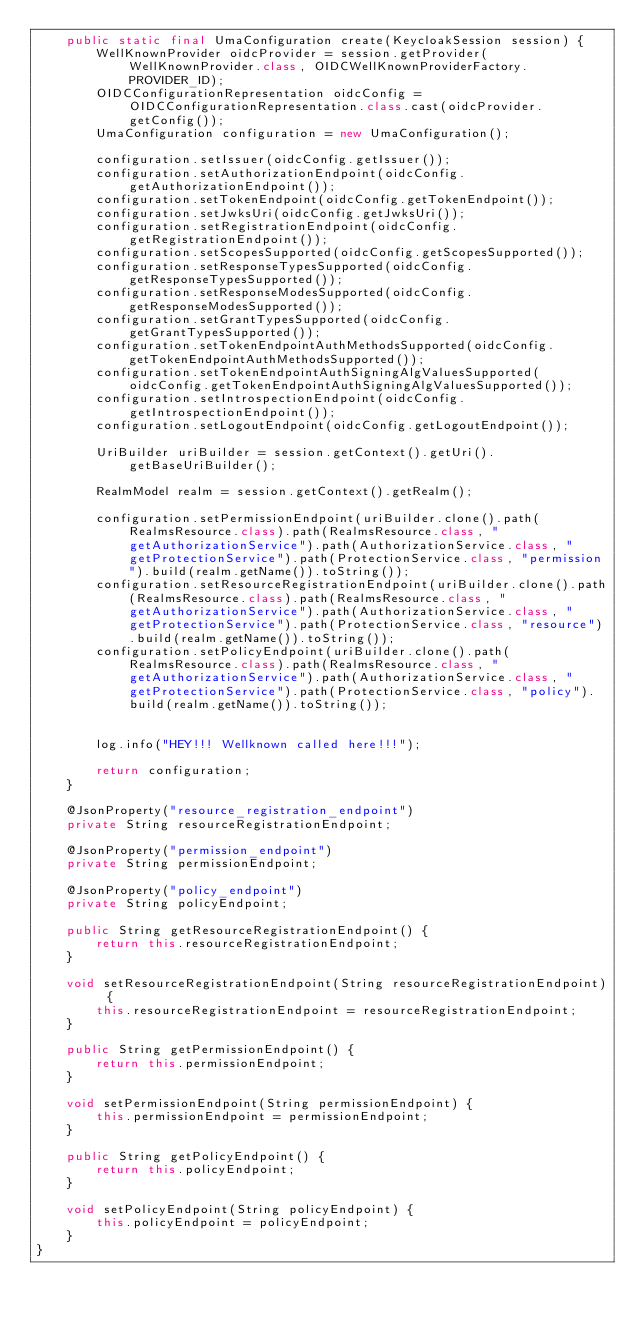Convert code to text. <code><loc_0><loc_0><loc_500><loc_500><_Java_>    public static final UmaConfiguration create(KeycloakSession session) {
        WellKnownProvider oidcProvider = session.getProvider(WellKnownProvider.class, OIDCWellKnownProviderFactory.PROVIDER_ID);
        OIDCConfigurationRepresentation oidcConfig = OIDCConfigurationRepresentation.class.cast(oidcProvider.getConfig());
        UmaConfiguration configuration = new UmaConfiguration();

        configuration.setIssuer(oidcConfig.getIssuer());
        configuration.setAuthorizationEndpoint(oidcConfig.getAuthorizationEndpoint());
        configuration.setTokenEndpoint(oidcConfig.getTokenEndpoint());
        configuration.setJwksUri(oidcConfig.getJwksUri());
        configuration.setRegistrationEndpoint(oidcConfig.getRegistrationEndpoint());
        configuration.setScopesSupported(oidcConfig.getScopesSupported());
        configuration.setResponseTypesSupported(oidcConfig.getResponseTypesSupported());
        configuration.setResponseModesSupported(oidcConfig.getResponseModesSupported());
        configuration.setGrantTypesSupported(oidcConfig.getGrantTypesSupported());
        configuration.setTokenEndpointAuthMethodsSupported(oidcConfig.getTokenEndpointAuthMethodsSupported());
        configuration.setTokenEndpointAuthSigningAlgValuesSupported(oidcConfig.getTokenEndpointAuthSigningAlgValuesSupported());
        configuration.setIntrospectionEndpoint(oidcConfig.getIntrospectionEndpoint());
        configuration.setLogoutEndpoint(oidcConfig.getLogoutEndpoint());

        UriBuilder uriBuilder = session.getContext().getUri().getBaseUriBuilder();

        RealmModel realm = session.getContext().getRealm();

        configuration.setPermissionEndpoint(uriBuilder.clone().path(RealmsResource.class).path(RealmsResource.class, "getAuthorizationService").path(AuthorizationService.class, "getProtectionService").path(ProtectionService.class, "permission").build(realm.getName()).toString());
        configuration.setResourceRegistrationEndpoint(uriBuilder.clone().path(RealmsResource.class).path(RealmsResource.class, "getAuthorizationService").path(AuthorizationService.class, "getProtectionService").path(ProtectionService.class, "resource").build(realm.getName()).toString());
        configuration.setPolicyEndpoint(uriBuilder.clone().path(RealmsResource.class).path(RealmsResource.class, "getAuthorizationService").path(AuthorizationService.class, "getProtectionService").path(ProtectionService.class, "policy").build(realm.getName()).toString());


        log.info("HEY!!! Wellknown called here!!!");

        return configuration;
    }

    @JsonProperty("resource_registration_endpoint")
    private String resourceRegistrationEndpoint;

    @JsonProperty("permission_endpoint")
    private String permissionEndpoint;
    
    @JsonProperty("policy_endpoint")
    private String policyEndpoint;

    public String getResourceRegistrationEndpoint() {
        return this.resourceRegistrationEndpoint;
    }

    void setResourceRegistrationEndpoint(String resourceRegistrationEndpoint) {
        this.resourceRegistrationEndpoint = resourceRegistrationEndpoint;
    }

    public String getPermissionEndpoint() {
        return this.permissionEndpoint;
    }

    void setPermissionEndpoint(String permissionEndpoint) {
        this.permissionEndpoint = permissionEndpoint;
    }
    
    public String getPolicyEndpoint() {
        return this.policyEndpoint;
    }

    void setPolicyEndpoint(String policyEndpoint) {
        this.policyEndpoint = policyEndpoint;
    }
}
</code> 